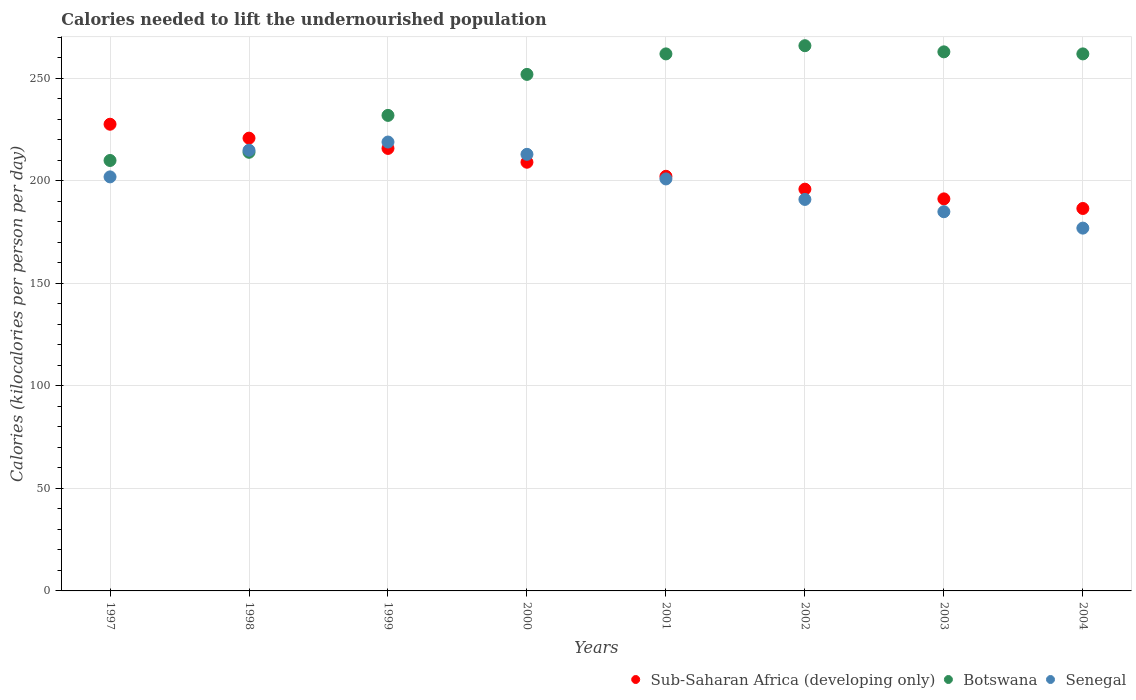What is the total calories needed to lift the undernourished population in Senegal in 1999?
Offer a very short reply. 219. Across all years, what is the maximum total calories needed to lift the undernourished population in Sub-Saharan Africa (developing only)?
Give a very brief answer. 227.68. Across all years, what is the minimum total calories needed to lift the undernourished population in Sub-Saharan Africa (developing only)?
Your answer should be very brief. 186.58. In which year was the total calories needed to lift the undernourished population in Sub-Saharan Africa (developing only) maximum?
Offer a terse response. 1997. What is the difference between the total calories needed to lift the undernourished population in Senegal in 2001 and that in 2003?
Your answer should be compact. 16. What is the difference between the total calories needed to lift the undernourished population in Senegal in 2004 and the total calories needed to lift the undernourished population in Sub-Saharan Africa (developing only) in 2002?
Keep it short and to the point. -19.01. What is the average total calories needed to lift the undernourished population in Botswana per year?
Your response must be concise. 245.12. In the year 2003, what is the difference between the total calories needed to lift the undernourished population in Sub-Saharan Africa (developing only) and total calories needed to lift the undernourished population in Senegal?
Provide a succinct answer. 6.26. In how many years, is the total calories needed to lift the undernourished population in Senegal greater than 70 kilocalories?
Provide a succinct answer. 8. What is the ratio of the total calories needed to lift the undernourished population in Sub-Saharan Africa (developing only) in 1997 to that in 1998?
Provide a succinct answer. 1.03. Is the total calories needed to lift the undernourished population in Senegal in 1998 less than that in 2002?
Give a very brief answer. No. What is the difference between the highest and the lowest total calories needed to lift the undernourished population in Sub-Saharan Africa (developing only)?
Your answer should be very brief. 41.1. In how many years, is the total calories needed to lift the undernourished population in Senegal greater than the average total calories needed to lift the undernourished population in Senegal taken over all years?
Provide a short and direct response. 5. Is the sum of the total calories needed to lift the undernourished population in Botswana in 2002 and 2003 greater than the maximum total calories needed to lift the undernourished population in Senegal across all years?
Offer a terse response. Yes. Does the total calories needed to lift the undernourished population in Sub-Saharan Africa (developing only) monotonically increase over the years?
Your answer should be compact. No. Is the total calories needed to lift the undernourished population in Sub-Saharan Africa (developing only) strictly greater than the total calories needed to lift the undernourished population in Botswana over the years?
Make the answer very short. No. Is the total calories needed to lift the undernourished population in Sub-Saharan Africa (developing only) strictly less than the total calories needed to lift the undernourished population in Senegal over the years?
Your answer should be very brief. No. How many dotlines are there?
Your answer should be compact. 3. How many years are there in the graph?
Provide a short and direct response. 8. Does the graph contain grids?
Provide a succinct answer. Yes. How many legend labels are there?
Make the answer very short. 3. What is the title of the graph?
Make the answer very short. Calories needed to lift the undernourished population. What is the label or title of the Y-axis?
Give a very brief answer. Calories (kilocalories per person per day). What is the Calories (kilocalories per person per day) of Sub-Saharan Africa (developing only) in 1997?
Your answer should be compact. 227.68. What is the Calories (kilocalories per person per day) in Botswana in 1997?
Your response must be concise. 210. What is the Calories (kilocalories per person per day) of Senegal in 1997?
Keep it short and to the point. 202. What is the Calories (kilocalories per person per day) of Sub-Saharan Africa (developing only) in 1998?
Make the answer very short. 220.89. What is the Calories (kilocalories per person per day) of Botswana in 1998?
Provide a short and direct response. 214. What is the Calories (kilocalories per person per day) in Senegal in 1998?
Ensure brevity in your answer.  215. What is the Calories (kilocalories per person per day) in Sub-Saharan Africa (developing only) in 1999?
Your answer should be very brief. 215.89. What is the Calories (kilocalories per person per day) of Botswana in 1999?
Provide a succinct answer. 232. What is the Calories (kilocalories per person per day) of Senegal in 1999?
Offer a terse response. 219. What is the Calories (kilocalories per person per day) of Sub-Saharan Africa (developing only) in 2000?
Ensure brevity in your answer.  209.15. What is the Calories (kilocalories per person per day) of Botswana in 2000?
Offer a very short reply. 252. What is the Calories (kilocalories per person per day) in Senegal in 2000?
Ensure brevity in your answer.  213. What is the Calories (kilocalories per person per day) of Sub-Saharan Africa (developing only) in 2001?
Offer a very short reply. 202.29. What is the Calories (kilocalories per person per day) of Botswana in 2001?
Your answer should be very brief. 262. What is the Calories (kilocalories per person per day) in Senegal in 2001?
Keep it short and to the point. 201. What is the Calories (kilocalories per person per day) of Sub-Saharan Africa (developing only) in 2002?
Your answer should be compact. 196.01. What is the Calories (kilocalories per person per day) in Botswana in 2002?
Keep it short and to the point. 266. What is the Calories (kilocalories per person per day) of Senegal in 2002?
Give a very brief answer. 191. What is the Calories (kilocalories per person per day) of Sub-Saharan Africa (developing only) in 2003?
Provide a succinct answer. 191.26. What is the Calories (kilocalories per person per day) in Botswana in 2003?
Ensure brevity in your answer.  263. What is the Calories (kilocalories per person per day) in Senegal in 2003?
Provide a succinct answer. 185. What is the Calories (kilocalories per person per day) of Sub-Saharan Africa (developing only) in 2004?
Offer a very short reply. 186.58. What is the Calories (kilocalories per person per day) in Botswana in 2004?
Give a very brief answer. 262. What is the Calories (kilocalories per person per day) in Senegal in 2004?
Provide a succinct answer. 177. Across all years, what is the maximum Calories (kilocalories per person per day) in Sub-Saharan Africa (developing only)?
Your answer should be very brief. 227.68. Across all years, what is the maximum Calories (kilocalories per person per day) of Botswana?
Ensure brevity in your answer.  266. Across all years, what is the maximum Calories (kilocalories per person per day) in Senegal?
Keep it short and to the point. 219. Across all years, what is the minimum Calories (kilocalories per person per day) of Sub-Saharan Africa (developing only)?
Your answer should be very brief. 186.58. Across all years, what is the minimum Calories (kilocalories per person per day) of Botswana?
Offer a terse response. 210. Across all years, what is the minimum Calories (kilocalories per person per day) in Senegal?
Your answer should be very brief. 177. What is the total Calories (kilocalories per person per day) of Sub-Saharan Africa (developing only) in the graph?
Your response must be concise. 1649.75. What is the total Calories (kilocalories per person per day) in Botswana in the graph?
Keep it short and to the point. 1961. What is the total Calories (kilocalories per person per day) in Senegal in the graph?
Keep it short and to the point. 1603. What is the difference between the Calories (kilocalories per person per day) of Sub-Saharan Africa (developing only) in 1997 and that in 1998?
Ensure brevity in your answer.  6.79. What is the difference between the Calories (kilocalories per person per day) in Botswana in 1997 and that in 1998?
Your answer should be very brief. -4. What is the difference between the Calories (kilocalories per person per day) of Senegal in 1997 and that in 1998?
Offer a very short reply. -13. What is the difference between the Calories (kilocalories per person per day) in Sub-Saharan Africa (developing only) in 1997 and that in 1999?
Give a very brief answer. 11.8. What is the difference between the Calories (kilocalories per person per day) in Senegal in 1997 and that in 1999?
Provide a succinct answer. -17. What is the difference between the Calories (kilocalories per person per day) in Sub-Saharan Africa (developing only) in 1997 and that in 2000?
Offer a terse response. 18.54. What is the difference between the Calories (kilocalories per person per day) in Botswana in 1997 and that in 2000?
Offer a very short reply. -42. What is the difference between the Calories (kilocalories per person per day) in Sub-Saharan Africa (developing only) in 1997 and that in 2001?
Ensure brevity in your answer.  25.4. What is the difference between the Calories (kilocalories per person per day) in Botswana in 1997 and that in 2001?
Keep it short and to the point. -52. What is the difference between the Calories (kilocalories per person per day) in Sub-Saharan Africa (developing only) in 1997 and that in 2002?
Your response must be concise. 31.68. What is the difference between the Calories (kilocalories per person per day) of Botswana in 1997 and that in 2002?
Offer a very short reply. -56. What is the difference between the Calories (kilocalories per person per day) of Sub-Saharan Africa (developing only) in 1997 and that in 2003?
Keep it short and to the point. 36.42. What is the difference between the Calories (kilocalories per person per day) of Botswana in 1997 and that in 2003?
Ensure brevity in your answer.  -53. What is the difference between the Calories (kilocalories per person per day) of Sub-Saharan Africa (developing only) in 1997 and that in 2004?
Make the answer very short. 41.1. What is the difference between the Calories (kilocalories per person per day) of Botswana in 1997 and that in 2004?
Keep it short and to the point. -52. What is the difference between the Calories (kilocalories per person per day) in Senegal in 1997 and that in 2004?
Keep it short and to the point. 25. What is the difference between the Calories (kilocalories per person per day) of Sub-Saharan Africa (developing only) in 1998 and that in 1999?
Offer a terse response. 5.01. What is the difference between the Calories (kilocalories per person per day) in Botswana in 1998 and that in 1999?
Keep it short and to the point. -18. What is the difference between the Calories (kilocalories per person per day) of Senegal in 1998 and that in 1999?
Offer a terse response. -4. What is the difference between the Calories (kilocalories per person per day) in Sub-Saharan Africa (developing only) in 1998 and that in 2000?
Make the answer very short. 11.75. What is the difference between the Calories (kilocalories per person per day) in Botswana in 1998 and that in 2000?
Keep it short and to the point. -38. What is the difference between the Calories (kilocalories per person per day) of Sub-Saharan Africa (developing only) in 1998 and that in 2001?
Provide a short and direct response. 18.61. What is the difference between the Calories (kilocalories per person per day) in Botswana in 1998 and that in 2001?
Provide a short and direct response. -48. What is the difference between the Calories (kilocalories per person per day) in Senegal in 1998 and that in 2001?
Ensure brevity in your answer.  14. What is the difference between the Calories (kilocalories per person per day) of Sub-Saharan Africa (developing only) in 1998 and that in 2002?
Your answer should be very brief. 24.89. What is the difference between the Calories (kilocalories per person per day) in Botswana in 1998 and that in 2002?
Provide a succinct answer. -52. What is the difference between the Calories (kilocalories per person per day) of Senegal in 1998 and that in 2002?
Your response must be concise. 24. What is the difference between the Calories (kilocalories per person per day) of Sub-Saharan Africa (developing only) in 1998 and that in 2003?
Your answer should be compact. 29.63. What is the difference between the Calories (kilocalories per person per day) of Botswana in 1998 and that in 2003?
Your answer should be compact. -49. What is the difference between the Calories (kilocalories per person per day) of Senegal in 1998 and that in 2003?
Keep it short and to the point. 30. What is the difference between the Calories (kilocalories per person per day) of Sub-Saharan Africa (developing only) in 1998 and that in 2004?
Offer a very short reply. 34.31. What is the difference between the Calories (kilocalories per person per day) of Botswana in 1998 and that in 2004?
Keep it short and to the point. -48. What is the difference between the Calories (kilocalories per person per day) in Senegal in 1998 and that in 2004?
Keep it short and to the point. 38. What is the difference between the Calories (kilocalories per person per day) of Sub-Saharan Africa (developing only) in 1999 and that in 2000?
Give a very brief answer. 6.74. What is the difference between the Calories (kilocalories per person per day) in Sub-Saharan Africa (developing only) in 1999 and that in 2001?
Your answer should be very brief. 13.6. What is the difference between the Calories (kilocalories per person per day) of Botswana in 1999 and that in 2001?
Ensure brevity in your answer.  -30. What is the difference between the Calories (kilocalories per person per day) in Sub-Saharan Africa (developing only) in 1999 and that in 2002?
Provide a short and direct response. 19.88. What is the difference between the Calories (kilocalories per person per day) of Botswana in 1999 and that in 2002?
Provide a succinct answer. -34. What is the difference between the Calories (kilocalories per person per day) in Senegal in 1999 and that in 2002?
Provide a short and direct response. 28. What is the difference between the Calories (kilocalories per person per day) in Sub-Saharan Africa (developing only) in 1999 and that in 2003?
Keep it short and to the point. 24.62. What is the difference between the Calories (kilocalories per person per day) in Botswana in 1999 and that in 2003?
Your response must be concise. -31. What is the difference between the Calories (kilocalories per person per day) of Sub-Saharan Africa (developing only) in 1999 and that in 2004?
Make the answer very short. 29.3. What is the difference between the Calories (kilocalories per person per day) of Botswana in 1999 and that in 2004?
Make the answer very short. -30. What is the difference between the Calories (kilocalories per person per day) in Senegal in 1999 and that in 2004?
Keep it short and to the point. 42. What is the difference between the Calories (kilocalories per person per day) of Sub-Saharan Africa (developing only) in 2000 and that in 2001?
Offer a very short reply. 6.86. What is the difference between the Calories (kilocalories per person per day) of Botswana in 2000 and that in 2001?
Your answer should be very brief. -10. What is the difference between the Calories (kilocalories per person per day) of Sub-Saharan Africa (developing only) in 2000 and that in 2002?
Offer a very short reply. 13.14. What is the difference between the Calories (kilocalories per person per day) of Botswana in 2000 and that in 2002?
Provide a short and direct response. -14. What is the difference between the Calories (kilocalories per person per day) in Sub-Saharan Africa (developing only) in 2000 and that in 2003?
Keep it short and to the point. 17.88. What is the difference between the Calories (kilocalories per person per day) of Botswana in 2000 and that in 2003?
Ensure brevity in your answer.  -11. What is the difference between the Calories (kilocalories per person per day) of Senegal in 2000 and that in 2003?
Keep it short and to the point. 28. What is the difference between the Calories (kilocalories per person per day) of Sub-Saharan Africa (developing only) in 2000 and that in 2004?
Provide a succinct answer. 22.56. What is the difference between the Calories (kilocalories per person per day) of Senegal in 2000 and that in 2004?
Make the answer very short. 36. What is the difference between the Calories (kilocalories per person per day) in Sub-Saharan Africa (developing only) in 2001 and that in 2002?
Keep it short and to the point. 6.28. What is the difference between the Calories (kilocalories per person per day) of Sub-Saharan Africa (developing only) in 2001 and that in 2003?
Give a very brief answer. 11.02. What is the difference between the Calories (kilocalories per person per day) in Senegal in 2001 and that in 2003?
Make the answer very short. 16. What is the difference between the Calories (kilocalories per person per day) in Sub-Saharan Africa (developing only) in 2001 and that in 2004?
Give a very brief answer. 15.7. What is the difference between the Calories (kilocalories per person per day) in Botswana in 2001 and that in 2004?
Offer a very short reply. 0. What is the difference between the Calories (kilocalories per person per day) in Senegal in 2001 and that in 2004?
Your answer should be very brief. 24. What is the difference between the Calories (kilocalories per person per day) in Sub-Saharan Africa (developing only) in 2002 and that in 2003?
Your answer should be compact. 4.74. What is the difference between the Calories (kilocalories per person per day) of Senegal in 2002 and that in 2003?
Your answer should be very brief. 6. What is the difference between the Calories (kilocalories per person per day) of Sub-Saharan Africa (developing only) in 2002 and that in 2004?
Ensure brevity in your answer.  9.42. What is the difference between the Calories (kilocalories per person per day) in Senegal in 2002 and that in 2004?
Ensure brevity in your answer.  14. What is the difference between the Calories (kilocalories per person per day) in Sub-Saharan Africa (developing only) in 2003 and that in 2004?
Make the answer very short. 4.68. What is the difference between the Calories (kilocalories per person per day) in Botswana in 2003 and that in 2004?
Provide a short and direct response. 1. What is the difference between the Calories (kilocalories per person per day) in Sub-Saharan Africa (developing only) in 1997 and the Calories (kilocalories per person per day) in Botswana in 1998?
Give a very brief answer. 13.68. What is the difference between the Calories (kilocalories per person per day) of Sub-Saharan Africa (developing only) in 1997 and the Calories (kilocalories per person per day) of Senegal in 1998?
Provide a succinct answer. 12.68. What is the difference between the Calories (kilocalories per person per day) of Botswana in 1997 and the Calories (kilocalories per person per day) of Senegal in 1998?
Offer a terse response. -5. What is the difference between the Calories (kilocalories per person per day) in Sub-Saharan Africa (developing only) in 1997 and the Calories (kilocalories per person per day) in Botswana in 1999?
Ensure brevity in your answer.  -4.32. What is the difference between the Calories (kilocalories per person per day) of Sub-Saharan Africa (developing only) in 1997 and the Calories (kilocalories per person per day) of Senegal in 1999?
Your response must be concise. 8.68. What is the difference between the Calories (kilocalories per person per day) of Sub-Saharan Africa (developing only) in 1997 and the Calories (kilocalories per person per day) of Botswana in 2000?
Offer a very short reply. -24.32. What is the difference between the Calories (kilocalories per person per day) in Sub-Saharan Africa (developing only) in 1997 and the Calories (kilocalories per person per day) in Senegal in 2000?
Keep it short and to the point. 14.68. What is the difference between the Calories (kilocalories per person per day) in Sub-Saharan Africa (developing only) in 1997 and the Calories (kilocalories per person per day) in Botswana in 2001?
Give a very brief answer. -34.32. What is the difference between the Calories (kilocalories per person per day) of Sub-Saharan Africa (developing only) in 1997 and the Calories (kilocalories per person per day) of Senegal in 2001?
Make the answer very short. 26.68. What is the difference between the Calories (kilocalories per person per day) in Sub-Saharan Africa (developing only) in 1997 and the Calories (kilocalories per person per day) in Botswana in 2002?
Make the answer very short. -38.32. What is the difference between the Calories (kilocalories per person per day) in Sub-Saharan Africa (developing only) in 1997 and the Calories (kilocalories per person per day) in Senegal in 2002?
Your answer should be compact. 36.68. What is the difference between the Calories (kilocalories per person per day) of Botswana in 1997 and the Calories (kilocalories per person per day) of Senegal in 2002?
Your response must be concise. 19. What is the difference between the Calories (kilocalories per person per day) of Sub-Saharan Africa (developing only) in 1997 and the Calories (kilocalories per person per day) of Botswana in 2003?
Give a very brief answer. -35.32. What is the difference between the Calories (kilocalories per person per day) in Sub-Saharan Africa (developing only) in 1997 and the Calories (kilocalories per person per day) in Senegal in 2003?
Ensure brevity in your answer.  42.68. What is the difference between the Calories (kilocalories per person per day) of Botswana in 1997 and the Calories (kilocalories per person per day) of Senegal in 2003?
Your answer should be very brief. 25. What is the difference between the Calories (kilocalories per person per day) of Sub-Saharan Africa (developing only) in 1997 and the Calories (kilocalories per person per day) of Botswana in 2004?
Provide a short and direct response. -34.32. What is the difference between the Calories (kilocalories per person per day) in Sub-Saharan Africa (developing only) in 1997 and the Calories (kilocalories per person per day) in Senegal in 2004?
Ensure brevity in your answer.  50.68. What is the difference between the Calories (kilocalories per person per day) of Sub-Saharan Africa (developing only) in 1998 and the Calories (kilocalories per person per day) of Botswana in 1999?
Ensure brevity in your answer.  -11.11. What is the difference between the Calories (kilocalories per person per day) in Sub-Saharan Africa (developing only) in 1998 and the Calories (kilocalories per person per day) in Senegal in 1999?
Offer a very short reply. 1.89. What is the difference between the Calories (kilocalories per person per day) in Sub-Saharan Africa (developing only) in 1998 and the Calories (kilocalories per person per day) in Botswana in 2000?
Give a very brief answer. -31.11. What is the difference between the Calories (kilocalories per person per day) of Sub-Saharan Africa (developing only) in 1998 and the Calories (kilocalories per person per day) of Senegal in 2000?
Your answer should be very brief. 7.89. What is the difference between the Calories (kilocalories per person per day) of Botswana in 1998 and the Calories (kilocalories per person per day) of Senegal in 2000?
Provide a succinct answer. 1. What is the difference between the Calories (kilocalories per person per day) of Sub-Saharan Africa (developing only) in 1998 and the Calories (kilocalories per person per day) of Botswana in 2001?
Your answer should be very brief. -41.11. What is the difference between the Calories (kilocalories per person per day) of Sub-Saharan Africa (developing only) in 1998 and the Calories (kilocalories per person per day) of Senegal in 2001?
Your response must be concise. 19.89. What is the difference between the Calories (kilocalories per person per day) of Sub-Saharan Africa (developing only) in 1998 and the Calories (kilocalories per person per day) of Botswana in 2002?
Your response must be concise. -45.11. What is the difference between the Calories (kilocalories per person per day) in Sub-Saharan Africa (developing only) in 1998 and the Calories (kilocalories per person per day) in Senegal in 2002?
Give a very brief answer. 29.89. What is the difference between the Calories (kilocalories per person per day) in Botswana in 1998 and the Calories (kilocalories per person per day) in Senegal in 2002?
Offer a very short reply. 23. What is the difference between the Calories (kilocalories per person per day) in Sub-Saharan Africa (developing only) in 1998 and the Calories (kilocalories per person per day) in Botswana in 2003?
Your answer should be compact. -42.11. What is the difference between the Calories (kilocalories per person per day) of Sub-Saharan Africa (developing only) in 1998 and the Calories (kilocalories per person per day) of Senegal in 2003?
Keep it short and to the point. 35.89. What is the difference between the Calories (kilocalories per person per day) in Botswana in 1998 and the Calories (kilocalories per person per day) in Senegal in 2003?
Your answer should be very brief. 29. What is the difference between the Calories (kilocalories per person per day) in Sub-Saharan Africa (developing only) in 1998 and the Calories (kilocalories per person per day) in Botswana in 2004?
Offer a very short reply. -41.11. What is the difference between the Calories (kilocalories per person per day) of Sub-Saharan Africa (developing only) in 1998 and the Calories (kilocalories per person per day) of Senegal in 2004?
Provide a short and direct response. 43.89. What is the difference between the Calories (kilocalories per person per day) in Sub-Saharan Africa (developing only) in 1999 and the Calories (kilocalories per person per day) in Botswana in 2000?
Your answer should be compact. -36.11. What is the difference between the Calories (kilocalories per person per day) of Sub-Saharan Africa (developing only) in 1999 and the Calories (kilocalories per person per day) of Senegal in 2000?
Your answer should be compact. 2.89. What is the difference between the Calories (kilocalories per person per day) of Sub-Saharan Africa (developing only) in 1999 and the Calories (kilocalories per person per day) of Botswana in 2001?
Offer a very short reply. -46.11. What is the difference between the Calories (kilocalories per person per day) of Sub-Saharan Africa (developing only) in 1999 and the Calories (kilocalories per person per day) of Senegal in 2001?
Your answer should be very brief. 14.89. What is the difference between the Calories (kilocalories per person per day) of Sub-Saharan Africa (developing only) in 1999 and the Calories (kilocalories per person per day) of Botswana in 2002?
Your answer should be compact. -50.11. What is the difference between the Calories (kilocalories per person per day) of Sub-Saharan Africa (developing only) in 1999 and the Calories (kilocalories per person per day) of Senegal in 2002?
Your answer should be compact. 24.89. What is the difference between the Calories (kilocalories per person per day) in Sub-Saharan Africa (developing only) in 1999 and the Calories (kilocalories per person per day) in Botswana in 2003?
Your answer should be very brief. -47.11. What is the difference between the Calories (kilocalories per person per day) of Sub-Saharan Africa (developing only) in 1999 and the Calories (kilocalories per person per day) of Senegal in 2003?
Keep it short and to the point. 30.89. What is the difference between the Calories (kilocalories per person per day) of Sub-Saharan Africa (developing only) in 1999 and the Calories (kilocalories per person per day) of Botswana in 2004?
Make the answer very short. -46.11. What is the difference between the Calories (kilocalories per person per day) in Sub-Saharan Africa (developing only) in 1999 and the Calories (kilocalories per person per day) in Senegal in 2004?
Provide a succinct answer. 38.89. What is the difference between the Calories (kilocalories per person per day) in Sub-Saharan Africa (developing only) in 2000 and the Calories (kilocalories per person per day) in Botswana in 2001?
Provide a short and direct response. -52.85. What is the difference between the Calories (kilocalories per person per day) of Sub-Saharan Africa (developing only) in 2000 and the Calories (kilocalories per person per day) of Senegal in 2001?
Your answer should be very brief. 8.15. What is the difference between the Calories (kilocalories per person per day) in Sub-Saharan Africa (developing only) in 2000 and the Calories (kilocalories per person per day) in Botswana in 2002?
Offer a very short reply. -56.85. What is the difference between the Calories (kilocalories per person per day) of Sub-Saharan Africa (developing only) in 2000 and the Calories (kilocalories per person per day) of Senegal in 2002?
Offer a very short reply. 18.15. What is the difference between the Calories (kilocalories per person per day) in Botswana in 2000 and the Calories (kilocalories per person per day) in Senegal in 2002?
Give a very brief answer. 61. What is the difference between the Calories (kilocalories per person per day) in Sub-Saharan Africa (developing only) in 2000 and the Calories (kilocalories per person per day) in Botswana in 2003?
Your answer should be very brief. -53.85. What is the difference between the Calories (kilocalories per person per day) of Sub-Saharan Africa (developing only) in 2000 and the Calories (kilocalories per person per day) of Senegal in 2003?
Give a very brief answer. 24.15. What is the difference between the Calories (kilocalories per person per day) of Sub-Saharan Africa (developing only) in 2000 and the Calories (kilocalories per person per day) of Botswana in 2004?
Keep it short and to the point. -52.85. What is the difference between the Calories (kilocalories per person per day) of Sub-Saharan Africa (developing only) in 2000 and the Calories (kilocalories per person per day) of Senegal in 2004?
Your response must be concise. 32.15. What is the difference between the Calories (kilocalories per person per day) of Sub-Saharan Africa (developing only) in 2001 and the Calories (kilocalories per person per day) of Botswana in 2002?
Give a very brief answer. -63.71. What is the difference between the Calories (kilocalories per person per day) of Sub-Saharan Africa (developing only) in 2001 and the Calories (kilocalories per person per day) of Senegal in 2002?
Provide a short and direct response. 11.29. What is the difference between the Calories (kilocalories per person per day) in Sub-Saharan Africa (developing only) in 2001 and the Calories (kilocalories per person per day) in Botswana in 2003?
Your answer should be compact. -60.71. What is the difference between the Calories (kilocalories per person per day) in Sub-Saharan Africa (developing only) in 2001 and the Calories (kilocalories per person per day) in Senegal in 2003?
Ensure brevity in your answer.  17.29. What is the difference between the Calories (kilocalories per person per day) in Sub-Saharan Africa (developing only) in 2001 and the Calories (kilocalories per person per day) in Botswana in 2004?
Your response must be concise. -59.71. What is the difference between the Calories (kilocalories per person per day) of Sub-Saharan Africa (developing only) in 2001 and the Calories (kilocalories per person per day) of Senegal in 2004?
Ensure brevity in your answer.  25.29. What is the difference between the Calories (kilocalories per person per day) of Sub-Saharan Africa (developing only) in 2002 and the Calories (kilocalories per person per day) of Botswana in 2003?
Your answer should be compact. -66.99. What is the difference between the Calories (kilocalories per person per day) of Sub-Saharan Africa (developing only) in 2002 and the Calories (kilocalories per person per day) of Senegal in 2003?
Give a very brief answer. 11.01. What is the difference between the Calories (kilocalories per person per day) of Sub-Saharan Africa (developing only) in 2002 and the Calories (kilocalories per person per day) of Botswana in 2004?
Keep it short and to the point. -65.99. What is the difference between the Calories (kilocalories per person per day) of Sub-Saharan Africa (developing only) in 2002 and the Calories (kilocalories per person per day) of Senegal in 2004?
Make the answer very short. 19.01. What is the difference between the Calories (kilocalories per person per day) of Botswana in 2002 and the Calories (kilocalories per person per day) of Senegal in 2004?
Keep it short and to the point. 89. What is the difference between the Calories (kilocalories per person per day) in Sub-Saharan Africa (developing only) in 2003 and the Calories (kilocalories per person per day) in Botswana in 2004?
Offer a terse response. -70.74. What is the difference between the Calories (kilocalories per person per day) of Sub-Saharan Africa (developing only) in 2003 and the Calories (kilocalories per person per day) of Senegal in 2004?
Your answer should be very brief. 14.26. What is the average Calories (kilocalories per person per day) in Sub-Saharan Africa (developing only) per year?
Your answer should be very brief. 206.22. What is the average Calories (kilocalories per person per day) in Botswana per year?
Provide a succinct answer. 245.12. What is the average Calories (kilocalories per person per day) of Senegal per year?
Your answer should be compact. 200.38. In the year 1997, what is the difference between the Calories (kilocalories per person per day) in Sub-Saharan Africa (developing only) and Calories (kilocalories per person per day) in Botswana?
Your answer should be compact. 17.68. In the year 1997, what is the difference between the Calories (kilocalories per person per day) in Sub-Saharan Africa (developing only) and Calories (kilocalories per person per day) in Senegal?
Offer a very short reply. 25.68. In the year 1998, what is the difference between the Calories (kilocalories per person per day) in Sub-Saharan Africa (developing only) and Calories (kilocalories per person per day) in Botswana?
Provide a short and direct response. 6.89. In the year 1998, what is the difference between the Calories (kilocalories per person per day) of Sub-Saharan Africa (developing only) and Calories (kilocalories per person per day) of Senegal?
Keep it short and to the point. 5.89. In the year 1999, what is the difference between the Calories (kilocalories per person per day) in Sub-Saharan Africa (developing only) and Calories (kilocalories per person per day) in Botswana?
Keep it short and to the point. -16.11. In the year 1999, what is the difference between the Calories (kilocalories per person per day) in Sub-Saharan Africa (developing only) and Calories (kilocalories per person per day) in Senegal?
Offer a terse response. -3.11. In the year 1999, what is the difference between the Calories (kilocalories per person per day) in Botswana and Calories (kilocalories per person per day) in Senegal?
Offer a very short reply. 13. In the year 2000, what is the difference between the Calories (kilocalories per person per day) of Sub-Saharan Africa (developing only) and Calories (kilocalories per person per day) of Botswana?
Provide a short and direct response. -42.85. In the year 2000, what is the difference between the Calories (kilocalories per person per day) in Sub-Saharan Africa (developing only) and Calories (kilocalories per person per day) in Senegal?
Your answer should be compact. -3.85. In the year 2000, what is the difference between the Calories (kilocalories per person per day) of Botswana and Calories (kilocalories per person per day) of Senegal?
Offer a very short reply. 39. In the year 2001, what is the difference between the Calories (kilocalories per person per day) of Sub-Saharan Africa (developing only) and Calories (kilocalories per person per day) of Botswana?
Your answer should be compact. -59.71. In the year 2001, what is the difference between the Calories (kilocalories per person per day) in Sub-Saharan Africa (developing only) and Calories (kilocalories per person per day) in Senegal?
Keep it short and to the point. 1.29. In the year 2001, what is the difference between the Calories (kilocalories per person per day) of Botswana and Calories (kilocalories per person per day) of Senegal?
Your answer should be compact. 61. In the year 2002, what is the difference between the Calories (kilocalories per person per day) in Sub-Saharan Africa (developing only) and Calories (kilocalories per person per day) in Botswana?
Give a very brief answer. -69.99. In the year 2002, what is the difference between the Calories (kilocalories per person per day) in Sub-Saharan Africa (developing only) and Calories (kilocalories per person per day) in Senegal?
Your response must be concise. 5.01. In the year 2002, what is the difference between the Calories (kilocalories per person per day) in Botswana and Calories (kilocalories per person per day) in Senegal?
Provide a short and direct response. 75. In the year 2003, what is the difference between the Calories (kilocalories per person per day) of Sub-Saharan Africa (developing only) and Calories (kilocalories per person per day) of Botswana?
Keep it short and to the point. -71.74. In the year 2003, what is the difference between the Calories (kilocalories per person per day) in Sub-Saharan Africa (developing only) and Calories (kilocalories per person per day) in Senegal?
Your answer should be very brief. 6.26. In the year 2003, what is the difference between the Calories (kilocalories per person per day) in Botswana and Calories (kilocalories per person per day) in Senegal?
Provide a succinct answer. 78. In the year 2004, what is the difference between the Calories (kilocalories per person per day) in Sub-Saharan Africa (developing only) and Calories (kilocalories per person per day) in Botswana?
Your answer should be compact. -75.42. In the year 2004, what is the difference between the Calories (kilocalories per person per day) in Sub-Saharan Africa (developing only) and Calories (kilocalories per person per day) in Senegal?
Ensure brevity in your answer.  9.58. What is the ratio of the Calories (kilocalories per person per day) of Sub-Saharan Africa (developing only) in 1997 to that in 1998?
Offer a terse response. 1.03. What is the ratio of the Calories (kilocalories per person per day) of Botswana in 1997 to that in 1998?
Your answer should be compact. 0.98. What is the ratio of the Calories (kilocalories per person per day) in Senegal in 1997 to that in 1998?
Your answer should be compact. 0.94. What is the ratio of the Calories (kilocalories per person per day) of Sub-Saharan Africa (developing only) in 1997 to that in 1999?
Provide a succinct answer. 1.05. What is the ratio of the Calories (kilocalories per person per day) of Botswana in 1997 to that in 1999?
Your answer should be very brief. 0.91. What is the ratio of the Calories (kilocalories per person per day) of Senegal in 1997 to that in 1999?
Ensure brevity in your answer.  0.92. What is the ratio of the Calories (kilocalories per person per day) of Sub-Saharan Africa (developing only) in 1997 to that in 2000?
Provide a short and direct response. 1.09. What is the ratio of the Calories (kilocalories per person per day) of Botswana in 1997 to that in 2000?
Make the answer very short. 0.83. What is the ratio of the Calories (kilocalories per person per day) in Senegal in 1997 to that in 2000?
Ensure brevity in your answer.  0.95. What is the ratio of the Calories (kilocalories per person per day) of Sub-Saharan Africa (developing only) in 1997 to that in 2001?
Give a very brief answer. 1.13. What is the ratio of the Calories (kilocalories per person per day) in Botswana in 1997 to that in 2001?
Make the answer very short. 0.8. What is the ratio of the Calories (kilocalories per person per day) in Sub-Saharan Africa (developing only) in 1997 to that in 2002?
Keep it short and to the point. 1.16. What is the ratio of the Calories (kilocalories per person per day) in Botswana in 1997 to that in 2002?
Ensure brevity in your answer.  0.79. What is the ratio of the Calories (kilocalories per person per day) in Senegal in 1997 to that in 2002?
Ensure brevity in your answer.  1.06. What is the ratio of the Calories (kilocalories per person per day) of Sub-Saharan Africa (developing only) in 1997 to that in 2003?
Ensure brevity in your answer.  1.19. What is the ratio of the Calories (kilocalories per person per day) in Botswana in 1997 to that in 2003?
Offer a very short reply. 0.8. What is the ratio of the Calories (kilocalories per person per day) of Senegal in 1997 to that in 2003?
Make the answer very short. 1.09. What is the ratio of the Calories (kilocalories per person per day) in Sub-Saharan Africa (developing only) in 1997 to that in 2004?
Your answer should be very brief. 1.22. What is the ratio of the Calories (kilocalories per person per day) of Botswana in 1997 to that in 2004?
Offer a very short reply. 0.8. What is the ratio of the Calories (kilocalories per person per day) in Senegal in 1997 to that in 2004?
Provide a short and direct response. 1.14. What is the ratio of the Calories (kilocalories per person per day) of Sub-Saharan Africa (developing only) in 1998 to that in 1999?
Make the answer very short. 1.02. What is the ratio of the Calories (kilocalories per person per day) of Botswana in 1998 to that in 1999?
Make the answer very short. 0.92. What is the ratio of the Calories (kilocalories per person per day) of Senegal in 1998 to that in 1999?
Your answer should be compact. 0.98. What is the ratio of the Calories (kilocalories per person per day) in Sub-Saharan Africa (developing only) in 1998 to that in 2000?
Your answer should be compact. 1.06. What is the ratio of the Calories (kilocalories per person per day) in Botswana in 1998 to that in 2000?
Your answer should be compact. 0.85. What is the ratio of the Calories (kilocalories per person per day) of Senegal in 1998 to that in 2000?
Make the answer very short. 1.01. What is the ratio of the Calories (kilocalories per person per day) of Sub-Saharan Africa (developing only) in 1998 to that in 2001?
Ensure brevity in your answer.  1.09. What is the ratio of the Calories (kilocalories per person per day) of Botswana in 1998 to that in 2001?
Make the answer very short. 0.82. What is the ratio of the Calories (kilocalories per person per day) in Senegal in 1998 to that in 2001?
Ensure brevity in your answer.  1.07. What is the ratio of the Calories (kilocalories per person per day) of Sub-Saharan Africa (developing only) in 1998 to that in 2002?
Provide a short and direct response. 1.13. What is the ratio of the Calories (kilocalories per person per day) of Botswana in 1998 to that in 2002?
Keep it short and to the point. 0.8. What is the ratio of the Calories (kilocalories per person per day) of Senegal in 1998 to that in 2002?
Make the answer very short. 1.13. What is the ratio of the Calories (kilocalories per person per day) in Sub-Saharan Africa (developing only) in 1998 to that in 2003?
Provide a succinct answer. 1.15. What is the ratio of the Calories (kilocalories per person per day) in Botswana in 1998 to that in 2003?
Give a very brief answer. 0.81. What is the ratio of the Calories (kilocalories per person per day) in Senegal in 1998 to that in 2003?
Your answer should be compact. 1.16. What is the ratio of the Calories (kilocalories per person per day) in Sub-Saharan Africa (developing only) in 1998 to that in 2004?
Provide a short and direct response. 1.18. What is the ratio of the Calories (kilocalories per person per day) of Botswana in 1998 to that in 2004?
Give a very brief answer. 0.82. What is the ratio of the Calories (kilocalories per person per day) of Senegal in 1998 to that in 2004?
Provide a short and direct response. 1.21. What is the ratio of the Calories (kilocalories per person per day) of Sub-Saharan Africa (developing only) in 1999 to that in 2000?
Ensure brevity in your answer.  1.03. What is the ratio of the Calories (kilocalories per person per day) in Botswana in 1999 to that in 2000?
Offer a very short reply. 0.92. What is the ratio of the Calories (kilocalories per person per day) of Senegal in 1999 to that in 2000?
Make the answer very short. 1.03. What is the ratio of the Calories (kilocalories per person per day) in Sub-Saharan Africa (developing only) in 1999 to that in 2001?
Offer a very short reply. 1.07. What is the ratio of the Calories (kilocalories per person per day) in Botswana in 1999 to that in 2001?
Your response must be concise. 0.89. What is the ratio of the Calories (kilocalories per person per day) in Senegal in 1999 to that in 2001?
Keep it short and to the point. 1.09. What is the ratio of the Calories (kilocalories per person per day) of Sub-Saharan Africa (developing only) in 1999 to that in 2002?
Keep it short and to the point. 1.1. What is the ratio of the Calories (kilocalories per person per day) of Botswana in 1999 to that in 2002?
Ensure brevity in your answer.  0.87. What is the ratio of the Calories (kilocalories per person per day) of Senegal in 1999 to that in 2002?
Make the answer very short. 1.15. What is the ratio of the Calories (kilocalories per person per day) in Sub-Saharan Africa (developing only) in 1999 to that in 2003?
Offer a very short reply. 1.13. What is the ratio of the Calories (kilocalories per person per day) in Botswana in 1999 to that in 2003?
Your response must be concise. 0.88. What is the ratio of the Calories (kilocalories per person per day) in Senegal in 1999 to that in 2003?
Ensure brevity in your answer.  1.18. What is the ratio of the Calories (kilocalories per person per day) of Sub-Saharan Africa (developing only) in 1999 to that in 2004?
Provide a succinct answer. 1.16. What is the ratio of the Calories (kilocalories per person per day) in Botswana in 1999 to that in 2004?
Provide a short and direct response. 0.89. What is the ratio of the Calories (kilocalories per person per day) in Senegal in 1999 to that in 2004?
Provide a succinct answer. 1.24. What is the ratio of the Calories (kilocalories per person per day) of Sub-Saharan Africa (developing only) in 2000 to that in 2001?
Your answer should be compact. 1.03. What is the ratio of the Calories (kilocalories per person per day) of Botswana in 2000 to that in 2001?
Provide a short and direct response. 0.96. What is the ratio of the Calories (kilocalories per person per day) in Senegal in 2000 to that in 2001?
Make the answer very short. 1.06. What is the ratio of the Calories (kilocalories per person per day) of Sub-Saharan Africa (developing only) in 2000 to that in 2002?
Make the answer very short. 1.07. What is the ratio of the Calories (kilocalories per person per day) in Senegal in 2000 to that in 2002?
Your answer should be very brief. 1.12. What is the ratio of the Calories (kilocalories per person per day) of Sub-Saharan Africa (developing only) in 2000 to that in 2003?
Ensure brevity in your answer.  1.09. What is the ratio of the Calories (kilocalories per person per day) in Botswana in 2000 to that in 2003?
Offer a terse response. 0.96. What is the ratio of the Calories (kilocalories per person per day) of Senegal in 2000 to that in 2003?
Keep it short and to the point. 1.15. What is the ratio of the Calories (kilocalories per person per day) in Sub-Saharan Africa (developing only) in 2000 to that in 2004?
Give a very brief answer. 1.12. What is the ratio of the Calories (kilocalories per person per day) of Botswana in 2000 to that in 2004?
Offer a very short reply. 0.96. What is the ratio of the Calories (kilocalories per person per day) in Senegal in 2000 to that in 2004?
Provide a short and direct response. 1.2. What is the ratio of the Calories (kilocalories per person per day) of Sub-Saharan Africa (developing only) in 2001 to that in 2002?
Provide a short and direct response. 1.03. What is the ratio of the Calories (kilocalories per person per day) in Botswana in 2001 to that in 2002?
Your response must be concise. 0.98. What is the ratio of the Calories (kilocalories per person per day) of Senegal in 2001 to that in 2002?
Your answer should be very brief. 1.05. What is the ratio of the Calories (kilocalories per person per day) in Sub-Saharan Africa (developing only) in 2001 to that in 2003?
Your answer should be compact. 1.06. What is the ratio of the Calories (kilocalories per person per day) in Senegal in 2001 to that in 2003?
Give a very brief answer. 1.09. What is the ratio of the Calories (kilocalories per person per day) in Sub-Saharan Africa (developing only) in 2001 to that in 2004?
Give a very brief answer. 1.08. What is the ratio of the Calories (kilocalories per person per day) of Senegal in 2001 to that in 2004?
Give a very brief answer. 1.14. What is the ratio of the Calories (kilocalories per person per day) of Sub-Saharan Africa (developing only) in 2002 to that in 2003?
Your answer should be compact. 1.02. What is the ratio of the Calories (kilocalories per person per day) in Botswana in 2002 to that in 2003?
Offer a very short reply. 1.01. What is the ratio of the Calories (kilocalories per person per day) of Senegal in 2002 to that in 2003?
Your answer should be very brief. 1.03. What is the ratio of the Calories (kilocalories per person per day) of Sub-Saharan Africa (developing only) in 2002 to that in 2004?
Ensure brevity in your answer.  1.05. What is the ratio of the Calories (kilocalories per person per day) of Botswana in 2002 to that in 2004?
Your answer should be compact. 1.02. What is the ratio of the Calories (kilocalories per person per day) of Senegal in 2002 to that in 2004?
Make the answer very short. 1.08. What is the ratio of the Calories (kilocalories per person per day) in Sub-Saharan Africa (developing only) in 2003 to that in 2004?
Provide a succinct answer. 1.03. What is the ratio of the Calories (kilocalories per person per day) of Botswana in 2003 to that in 2004?
Provide a succinct answer. 1. What is the ratio of the Calories (kilocalories per person per day) of Senegal in 2003 to that in 2004?
Ensure brevity in your answer.  1.05. What is the difference between the highest and the second highest Calories (kilocalories per person per day) of Sub-Saharan Africa (developing only)?
Your response must be concise. 6.79. What is the difference between the highest and the second highest Calories (kilocalories per person per day) in Senegal?
Ensure brevity in your answer.  4. What is the difference between the highest and the lowest Calories (kilocalories per person per day) in Sub-Saharan Africa (developing only)?
Give a very brief answer. 41.1. What is the difference between the highest and the lowest Calories (kilocalories per person per day) of Senegal?
Your answer should be very brief. 42. 